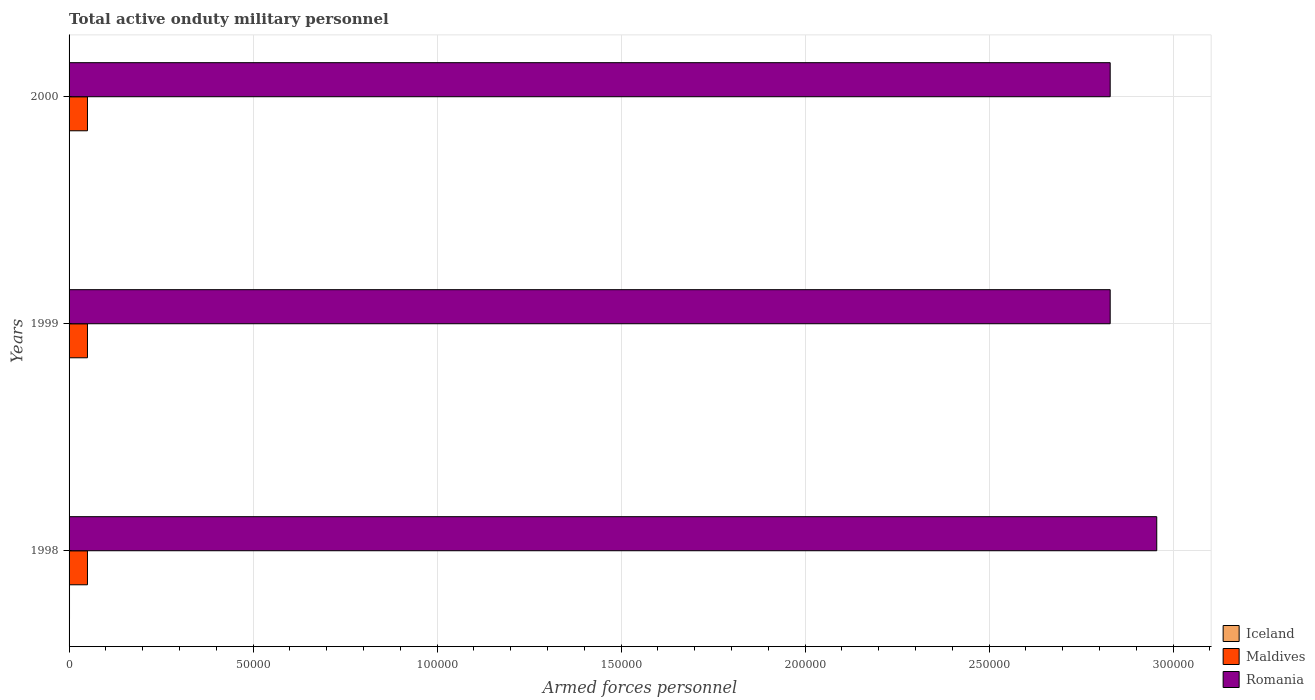How many groups of bars are there?
Offer a very short reply. 3. Are the number of bars on each tick of the Y-axis equal?
Make the answer very short. Yes. How many bars are there on the 1st tick from the top?
Your answer should be very brief. 3. What is the number of armed forces personnel in Iceland in 2000?
Give a very brief answer. 100. Across all years, what is the maximum number of armed forces personnel in Maldives?
Your answer should be compact. 5000. What is the total number of armed forces personnel in Iceland in the graph?
Provide a short and direct response. 320. What is the difference between the number of armed forces personnel in Romania in 2000 and the number of armed forces personnel in Iceland in 1998?
Keep it short and to the point. 2.83e+05. What is the average number of armed forces personnel in Maldives per year?
Offer a terse response. 5000. In the year 2000, what is the difference between the number of armed forces personnel in Romania and number of armed forces personnel in Iceland?
Give a very brief answer. 2.83e+05. What is the ratio of the number of armed forces personnel in Iceland in 1998 to that in 2000?
Provide a short and direct response. 1.2. Is the number of armed forces personnel in Iceland in 1998 less than that in 1999?
Provide a succinct answer. No. Is the difference between the number of armed forces personnel in Romania in 1998 and 2000 greater than the difference between the number of armed forces personnel in Iceland in 1998 and 2000?
Offer a very short reply. Yes. What is the difference between the highest and the lowest number of armed forces personnel in Iceland?
Offer a very short reply. 20. Is the sum of the number of armed forces personnel in Iceland in 1998 and 2000 greater than the maximum number of armed forces personnel in Maldives across all years?
Make the answer very short. No. What does the 2nd bar from the top in 1999 represents?
Make the answer very short. Maldives. What does the 2nd bar from the bottom in 1999 represents?
Provide a short and direct response. Maldives. Is it the case that in every year, the sum of the number of armed forces personnel in Romania and number of armed forces personnel in Iceland is greater than the number of armed forces personnel in Maldives?
Your response must be concise. Yes. How many bars are there?
Your answer should be very brief. 9. Are all the bars in the graph horizontal?
Your answer should be compact. Yes. What is the difference between two consecutive major ticks on the X-axis?
Provide a short and direct response. 5.00e+04. Are the values on the major ticks of X-axis written in scientific E-notation?
Provide a succinct answer. No. Does the graph contain any zero values?
Your response must be concise. No. How many legend labels are there?
Make the answer very short. 3. What is the title of the graph?
Provide a short and direct response. Total active onduty military personnel. What is the label or title of the X-axis?
Offer a very short reply. Armed forces personnel. What is the Armed forces personnel of Iceland in 1998?
Ensure brevity in your answer.  120. What is the Armed forces personnel of Maldives in 1998?
Offer a very short reply. 5000. What is the Armed forces personnel of Romania in 1998?
Ensure brevity in your answer.  2.96e+05. What is the Armed forces personnel of Iceland in 1999?
Your response must be concise. 100. What is the Armed forces personnel in Maldives in 1999?
Offer a terse response. 5000. What is the Armed forces personnel in Romania in 1999?
Ensure brevity in your answer.  2.83e+05. What is the Armed forces personnel in Iceland in 2000?
Provide a short and direct response. 100. What is the Armed forces personnel in Maldives in 2000?
Your answer should be compact. 5000. What is the Armed forces personnel in Romania in 2000?
Ensure brevity in your answer.  2.83e+05. Across all years, what is the maximum Armed forces personnel of Iceland?
Offer a terse response. 120. Across all years, what is the maximum Armed forces personnel of Maldives?
Your answer should be compact. 5000. Across all years, what is the maximum Armed forces personnel of Romania?
Provide a succinct answer. 2.96e+05. Across all years, what is the minimum Armed forces personnel in Iceland?
Provide a short and direct response. 100. Across all years, what is the minimum Armed forces personnel of Maldives?
Ensure brevity in your answer.  5000. Across all years, what is the minimum Armed forces personnel in Romania?
Make the answer very short. 2.83e+05. What is the total Armed forces personnel of Iceland in the graph?
Offer a terse response. 320. What is the total Armed forces personnel in Maldives in the graph?
Keep it short and to the point. 1.50e+04. What is the total Armed forces personnel of Romania in the graph?
Offer a very short reply. 8.61e+05. What is the difference between the Armed forces personnel in Maldives in 1998 and that in 1999?
Provide a short and direct response. 0. What is the difference between the Armed forces personnel of Romania in 1998 and that in 1999?
Offer a terse response. 1.26e+04. What is the difference between the Armed forces personnel in Romania in 1998 and that in 2000?
Make the answer very short. 1.26e+04. What is the difference between the Armed forces personnel in Iceland in 1999 and that in 2000?
Provide a short and direct response. 0. What is the difference between the Armed forces personnel in Iceland in 1998 and the Armed forces personnel in Maldives in 1999?
Keep it short and to the point. -4880. What is the difference between the Armed forces personnel of Iceland in 1998 and the Armed forces personnel of Romania in 1999?
Your answer should be very brief. -2.83e+05. What is the difference between the Armed forces personnel of Maldives in 1998 and the Armed forces personnel of Romania in 1999?
Give a very brief answer. -2.78e+05. What is the difference between the Armed forces personnel in Iceland in 1998 and the Armed forces personnel in Maldives in 2000?
Your response must be concise. -4880. What is the difference between the Armed forces personnel in Iceland in 1998 and the Armed forces personnel in Romania in 2000?
Your answer should be very brief. -2.83e+05. What is the difference between the Armed forces personnel in Maldives in 1998 and the Armed forces personnel in Romania in 2000?
Ensure brevity in your answer.  -2.78e+05. What is the difference between the Armed forces personnel in Iceland in 1999 and the Armed forces personnel in Maldives in 2000?
Provide a short and direct response. -4900. What is the difference between the Armed forces personnel of Iceland in 1999 and the Armed forces personnel of Romania in 2000?
Keep it short and to the point. -2.83e+05. What is the difference between the Armed forces personnel of Maldives in 1999 and the Armed forces personnel of Romania in 2000?
Provide a short and direct response. -2.78e+05. What is the average Armed forces personnel in Iceland per year?
Offer a very short reply. 106.67. What is the average Armed forces personnel in Romania per year?
Offer a very short reply. 2.87e+05. In the year 1998, what is the difference between the Armed forces personnel in Iceland and Armed forces personnel in Maldives?
Ensure brevity in your answer.  -4880. In the year 1998, what is the difference between the Armed forces personnel in Iceland and Armed forces personnel in Romania?
Keep it short and to the point. -2.95e+05. In the year 1998, what is the difference between the Armed forces personnel of Maldives and Armed forces personnel of Romania?
Provide a succinct answer. -2.91e+05. In the year 1999, what is the difference between the Armed forces personnel of Iceland and Armed forces personnel of Maldives?
Provide a succinct answer. -4900. In the year 1999, what is the difference between the Armed forces personnel of Iceland and Armed forces personnel of Romania?
Your answer should be very brief. -2.83e+05. In the year 1999, what is the difference between the Armed forces personnel in Maldives and Armed forces personnel in Romania?
Your answer should be very brief. -2.78e+05. In the year 2000, what is the difference between the Armed forces personnel in Iceland and Armed forces personnel in Maldives?
Offer a very short reply. -4900. In the year 2000, what is the difference between the Armed forces personnel in Iceland and Armed forces personnel in Romania?
Ensure brevity in your answer.  -2.83e+05. In the year 2000, what is the difference between the Armed forces personnel of Maldives and Armed forces personnel of Romania?
Your answer should be very brief. -2.78e+05. What is the ratio of the Armed forces personnel of Maldives in 1998 to that in 1999?
Provide a succinct answer. 1. What is the ratio of the Armed forces personnel of Romania in 1998 to that in 1999?
Provide a succinct answer. 1.04. What is the ratio of the Armed forces personnel of Maldives in 1998 to that in 2000?
Offer a very short reply. 1. What is the ratio of the Armed forces personnel in Romania in 1998 to that in 2000?
Your answer should be very brief. 1.04. What is the ratio of the Armed forces personnel of Iceland in 1999 to that in 2000?
Offer a very short reply. 1. What is the ratio of the Armed forces personnel in Romania in 1999 to that in 2000?
Your answer should be compact. 1. What is the difference between the highest and the second highest Armed forces personnel of Iceland?
Make the answer very short. 20. What is the difference between the highest and the second highest Armed forces personnel in Maldives?
Give a very brief answer. 0. What is the difference between the highest and the second highest Armed forces personnel of Romania?
Make the answer very short. 1.26e+04. What is the difference between the highest and the lowest Armed forces personnel of Iceland?
Your answer should be very brief. 20. What is the difference between the highest and the lowest Armed forces personnel in Romania?
Provide a succinct answer. 1.26e+04. 